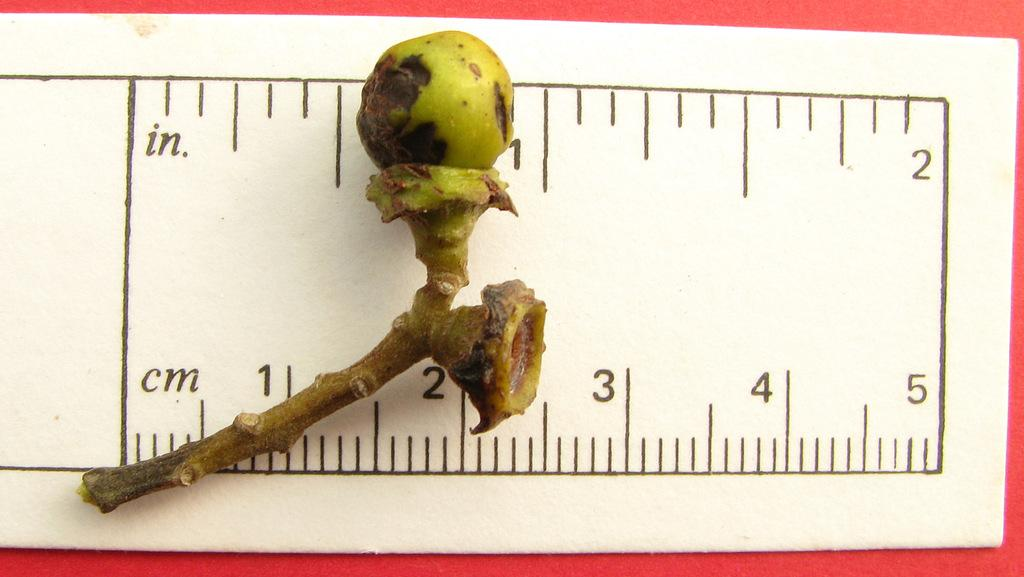<image>
Provide a brief description of the given image. A dried up pod sitting on a ruler by the 1 inch mark. 